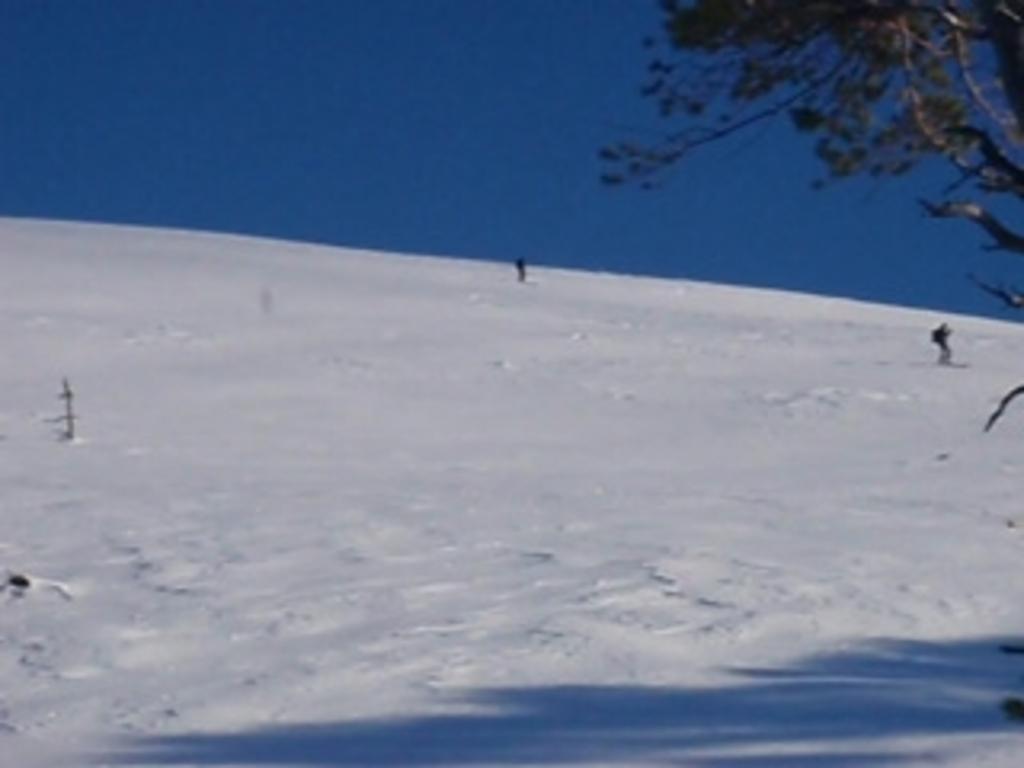How would you summarize this image in a sentence or two? In the image we can see there is a ground covered with snow and there is a tree. There is a clear sky. 